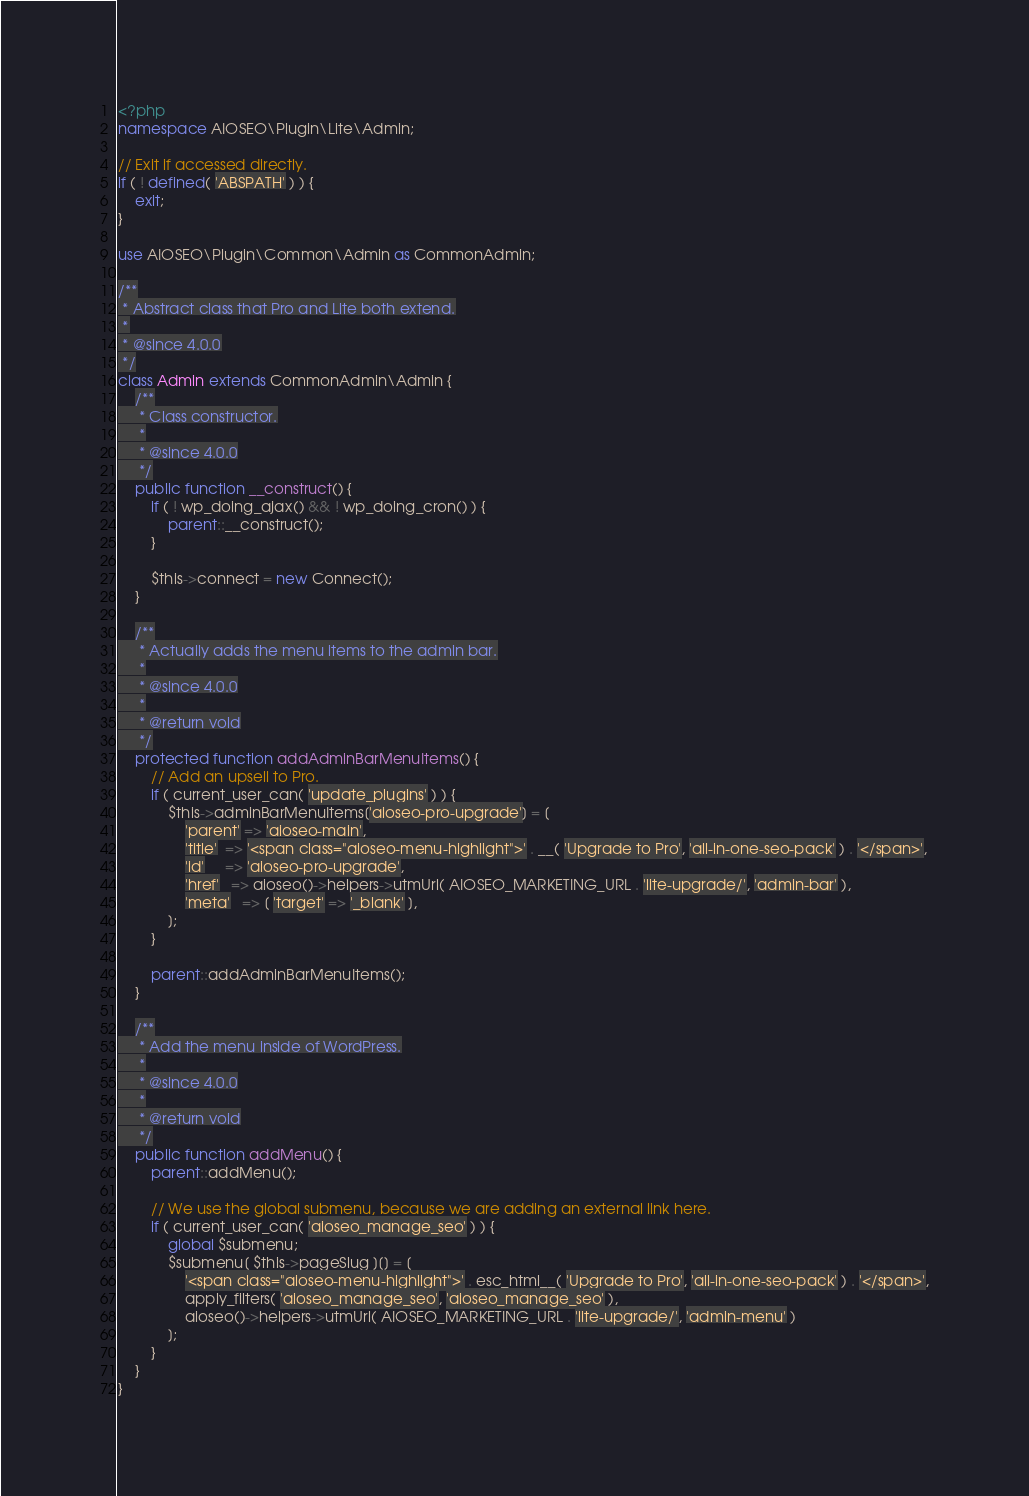Convert code to text. <code><loc_0><loc_0><loc_500><loc_500><_PHP_><?php
namespace AIOSEO\Plugin\Lite\Admin;

// Exit if accessed directly.
if ( ! defined( 'ABSPATH' ) ) {
	exit;
}

use AIOSEO\Plugin\Common\Admin as CommonAdmin;

/**
 * Abstract class that Pro and Lite both extend.
 *
 * @since 4.0.0
 */
class Admin extends CommonAdmin\Admin {
	/**
	 * Class constructor.
	 *
	 * @since 4.0.0
	 */
	public function __construct() {
		if ( ! wp_doing_ajax() && ! wp_doing_cron() ) {
			parent::__construct();
		}

		$this->connect = new Connect();
	}

	/**
	 * Actually adds the menu items to the admin bar.
	 *
	 * @since 4.0.0
	 *
	 * @return void
	 */
	protected function addAdminBarMenuItems() {
		// Add an upsell to Pro.
		if ( current_user_can( 'update_plugins' ) ) {
			$this->adminBarMenuItems['aioseo-pro-upgrade'] = [
				'parent' => 'aioseo-main',
				'title'  => '<span class="aioseo-menu-highlight">' . __( 'Upgrade to Pro', 'all-in-one-seo-pack' ) . '</span>',
				'id'     => 'aioseo-pro-upgrade',
				'href'   => aioseo()->helpers->utmUrl( AIOSEO_MARKETING_URL . 'lite-upgrade/', 'admin-bar' ),
				'meta'   => [ 'target' => '_blank' ],
			];
		}

		parent::addAdminBarMenuItems();
	}

	/**
	 * Add the menu inside of WordPress.
	 *
	 * @since 4.0.0
	 *
	 * @return void
	 */
	public function addMenu() {
		parent::addMenu();

		// We use the global submenu, because we are adding an external link here.
		if ( current_user_can( 'aioseo_manage_seo' ) ) {
			global $submenu;
			$submenu[ $this->pageSlug ][] = [
				'<span class="aioseo-menu-highlight">' . esc_html__( 'Upgrade to Pro', 'all-in-one-seo-pack' ) . '</span>',
				apply_filters( 'aioseo_manage_seo', 'aioseo_manage_seo' ),
				aioseo()->helpers->utmUrl( AIOSEO_MARKETING_URL . 'lite-upgrade/', 'admin-menu' )
			];
		}
	}
}</code> 